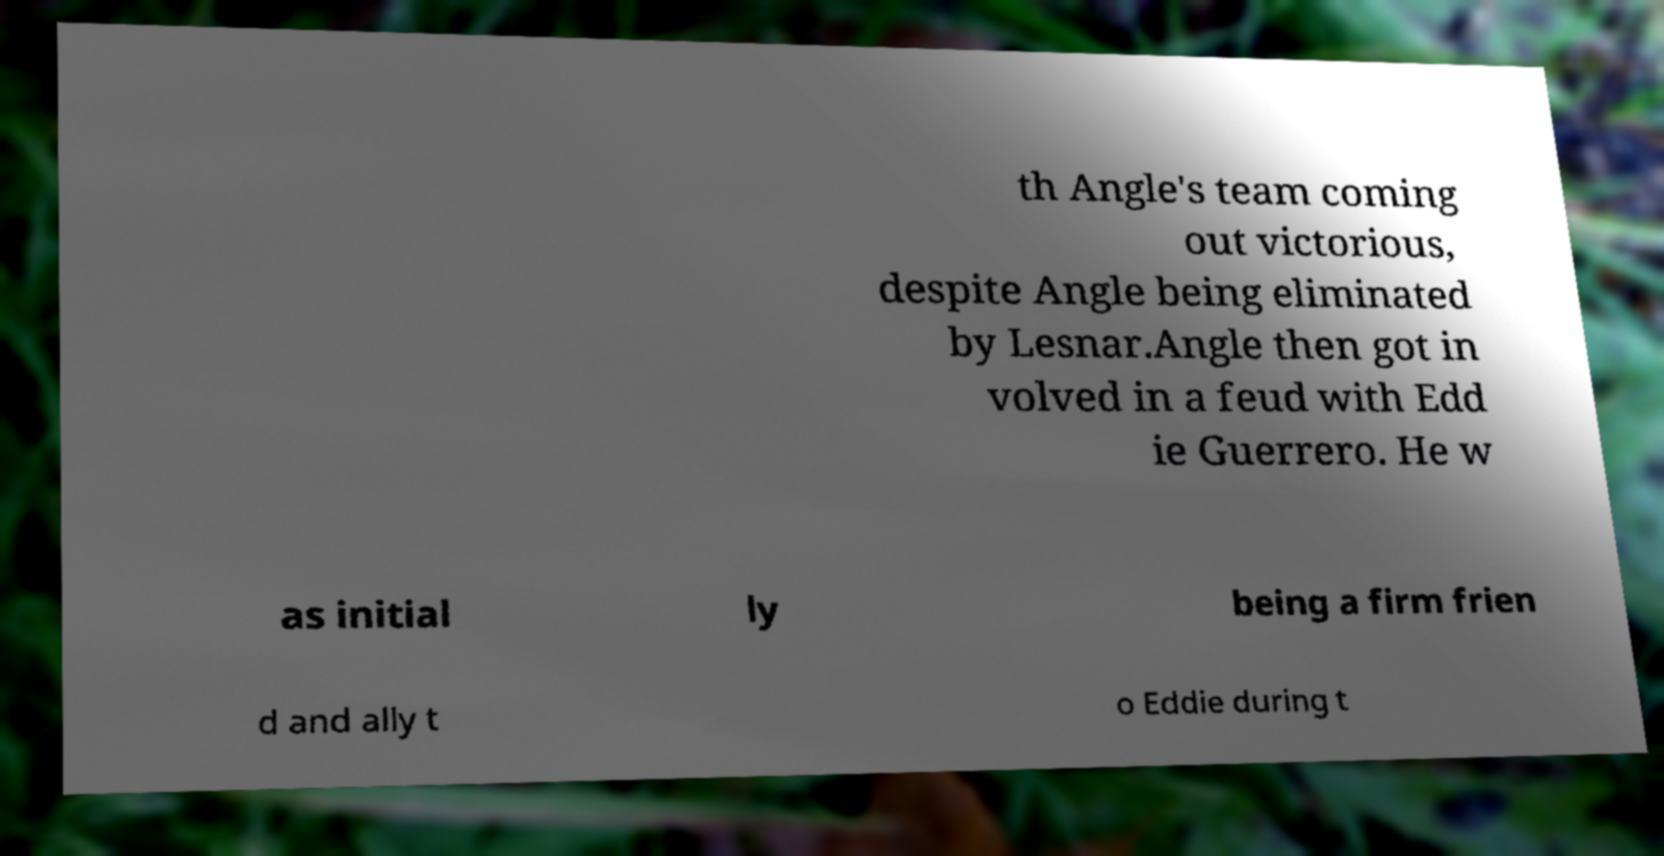Please identify and transcribe the text found in this image. th Angle's team coming out victorious, despite Angle being eliminated by Lesnar.Angle then got in volved in a feud with Edd ie Guerrero. He w as initial ly being a firm frien d and ally t o Eddie during t 